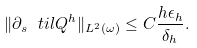<formula> <loc_0><loc_0><loc_500><loc_500>\| \partial _ { s } \ t i l { Q } ^ { h } \| _ { L ^ { 2 } ( \omega ) } \leq C \frac { h \epsilon _ { h } } { \delta _ { h } } .</formula> 